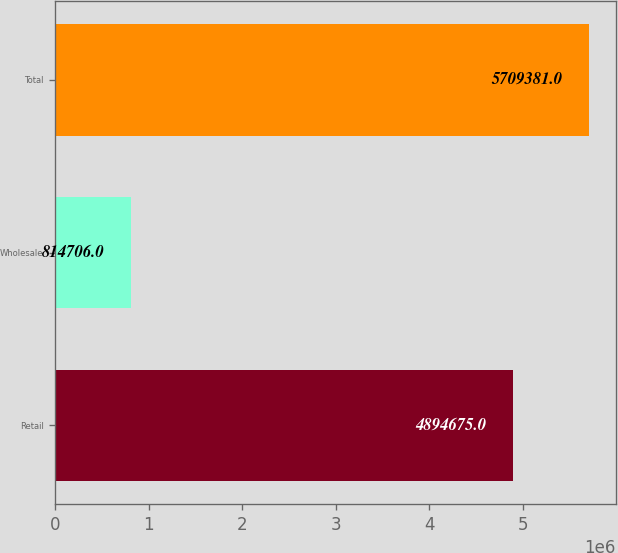Convert chart. <chart><loc_0><loc_0><loc_500><loc_500><bar_chart><fcel>Retail<fcel>Wholesale<fcel>Total<nl><fcel>4.89468e+06<fcel>814706<fcel>5.70938e+06<nl></chart> 